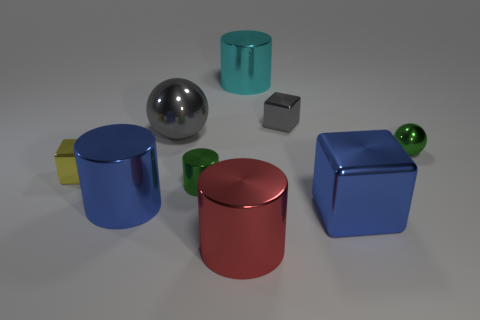There is a blue thing on the left side of the tiny gray object; are there any gray blocks in front of it?
Ensure brevity in your answer.  No. There is a large blue metallic thing on the left side of the large gray metallic ball; does it have the same shape as the red metal thing?
Offer a terse response. Yes. Are there any other things that have the same shape as the large red object?
Make the answer very short. Yes. How many cylinders are big gray objects or blue metal things?
Offer a very short reply. 1. How many small blue matte cylinders are there?
Offer a terse response. 0. What size is the blue metal thing to the left of the shiny block that is behind the small ball?
Your answer should be compact. Large. How many other things are the same size as the red metallic thing?
Provide a short and direct response. 4. There is a blue cylinder; what number of small green spheres are to the left of it?
Ensure brevity in your answer.  0. What is the size of the green sphere?
Ensure brevity in your answer.  Small. Is the material of the small block on the right side of the cyan metallic thing the same as the large cylinder behind the yellow thing?
Give a very brief answer. Yes. 